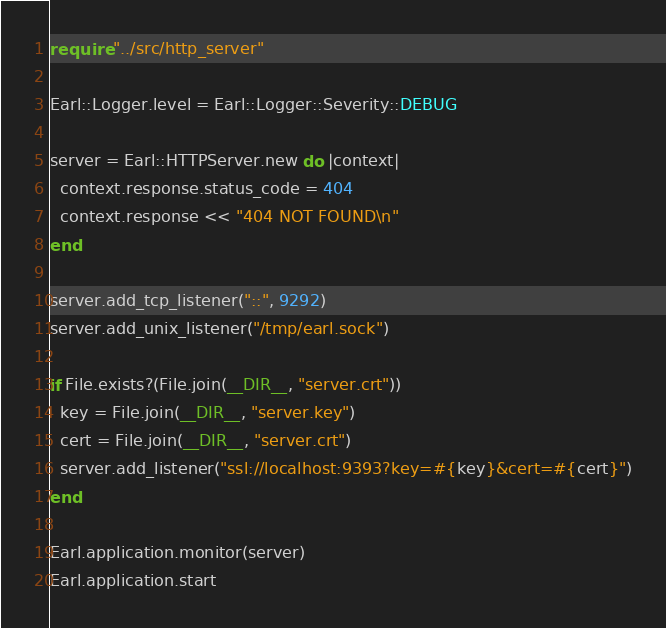<code> <loc_0><loc_0><loc_500><loc_500><_Crystal_>require "../src/http_server"

Earl::Logger.level = Earl::Logger::Severity::DEBUG

server = Earl::HTTPServer.new do |context|
  context.response.status_code = 404
  context.response << "404 NOT FOUND\n"
end

server.add_tcp_listener("::", 9292)
server.add_unix_listener("/tmp/earl.sock")

if File.exists?(File.join(__DIR__, "server.crt"))
  key = File.join(__DIR__, "server.key")
  cert = File.join(__DIR__, "server.crt")
  server.add_listener("ssl://localhost:9393?key=#{key}&cert=#{cert}")
end

Earl.application.monitor(server)
Earl.application.start
</code> 